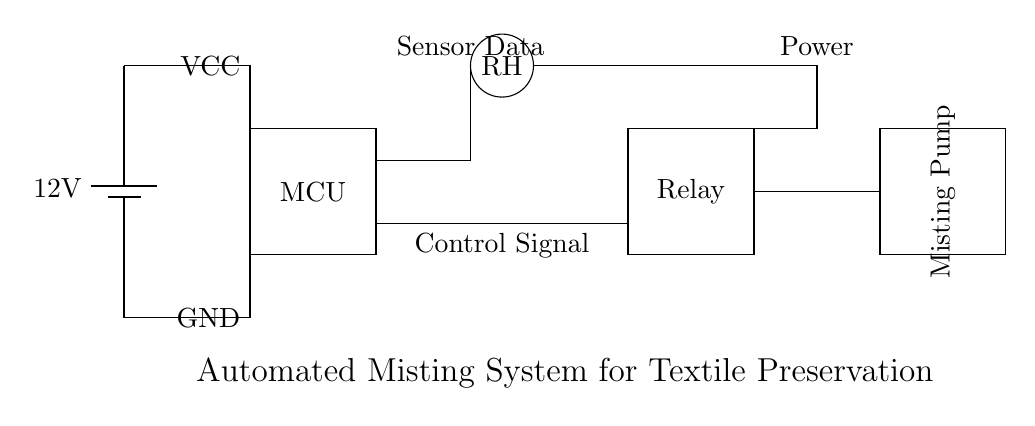What is the voltage of this circuit? The voltage is twelve volts, which is the value indicated next to the battery symbol in the circuit diagram.
Answer: twelve volts What is the primary function of the microcontroller in this circuit? The microcontroller is responsible for processing the data from the humidity sensor and triggering the relay to control the misting pump based on humidity levels.
Answer: processing data What component controls the misting pump? The relay controls the misting pump by receiving a control signal from the microcontroller and enabling the pump to operate when needed.
Answer: relay How many main components are there in this circuit? There are four main components: the microcontroller, humidity sensor, relay, and misting pump.
Answer: four What is the purpose of the humidity sensor in the circuit? The humidity sensor measures the relative humidity levels in the environment and sends this data to the microcontroller for decision-making regarding misting.
Answer: measure humidity Which direction does the control signal flow in the circuit? The control signal flows from the microcontroller to the relay, indicating when to activate the misting pump.
Answer: microcontroller to relay 